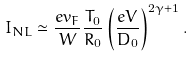Convert formula to latex. <formula><loc_0><loc_0><loc_500><loc_500>I _ { N L } \simeq \frac { e v _ { F } } { W } \frac { T _ { 0 } } { R _ { 0 } } \left ( \frac { e V } { D _ { 0 } } \right ) ^ { 2 \gamma + 1 } .</formula> 